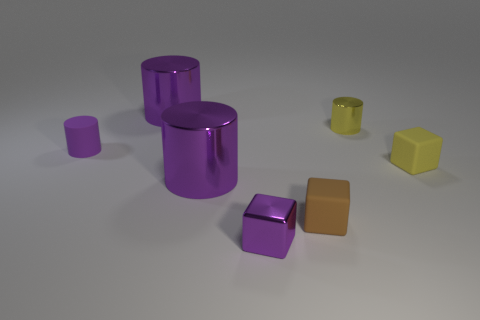Subtract 3 cylinders. How many cylinders are left? 1 Subtract all purple metallic cubes. How many cubes are left? 2 Add 2 tiny metallic cylinders. How many tiny metallic cylinders are left? 3 Add 6 large purple things. How many large purple things exist? 8 Add 2 brown matte cubes. How many objects exist? 9 Subtract all yellow cylinders. How many cylinders are left? 3 Subtract 0 purple spheres. How many objects are left? 7 Subtract all blocks. How many objects are left? 4 Subtract all purple cubes. Subtract all brown cylinders. How many cubes are left? 2 Subtract all blue cylinders. How many red cubes are left? 0 